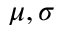<formula> <loc_0><loc_0><loc_500><loc_500>\mu , \sigma</formula> 